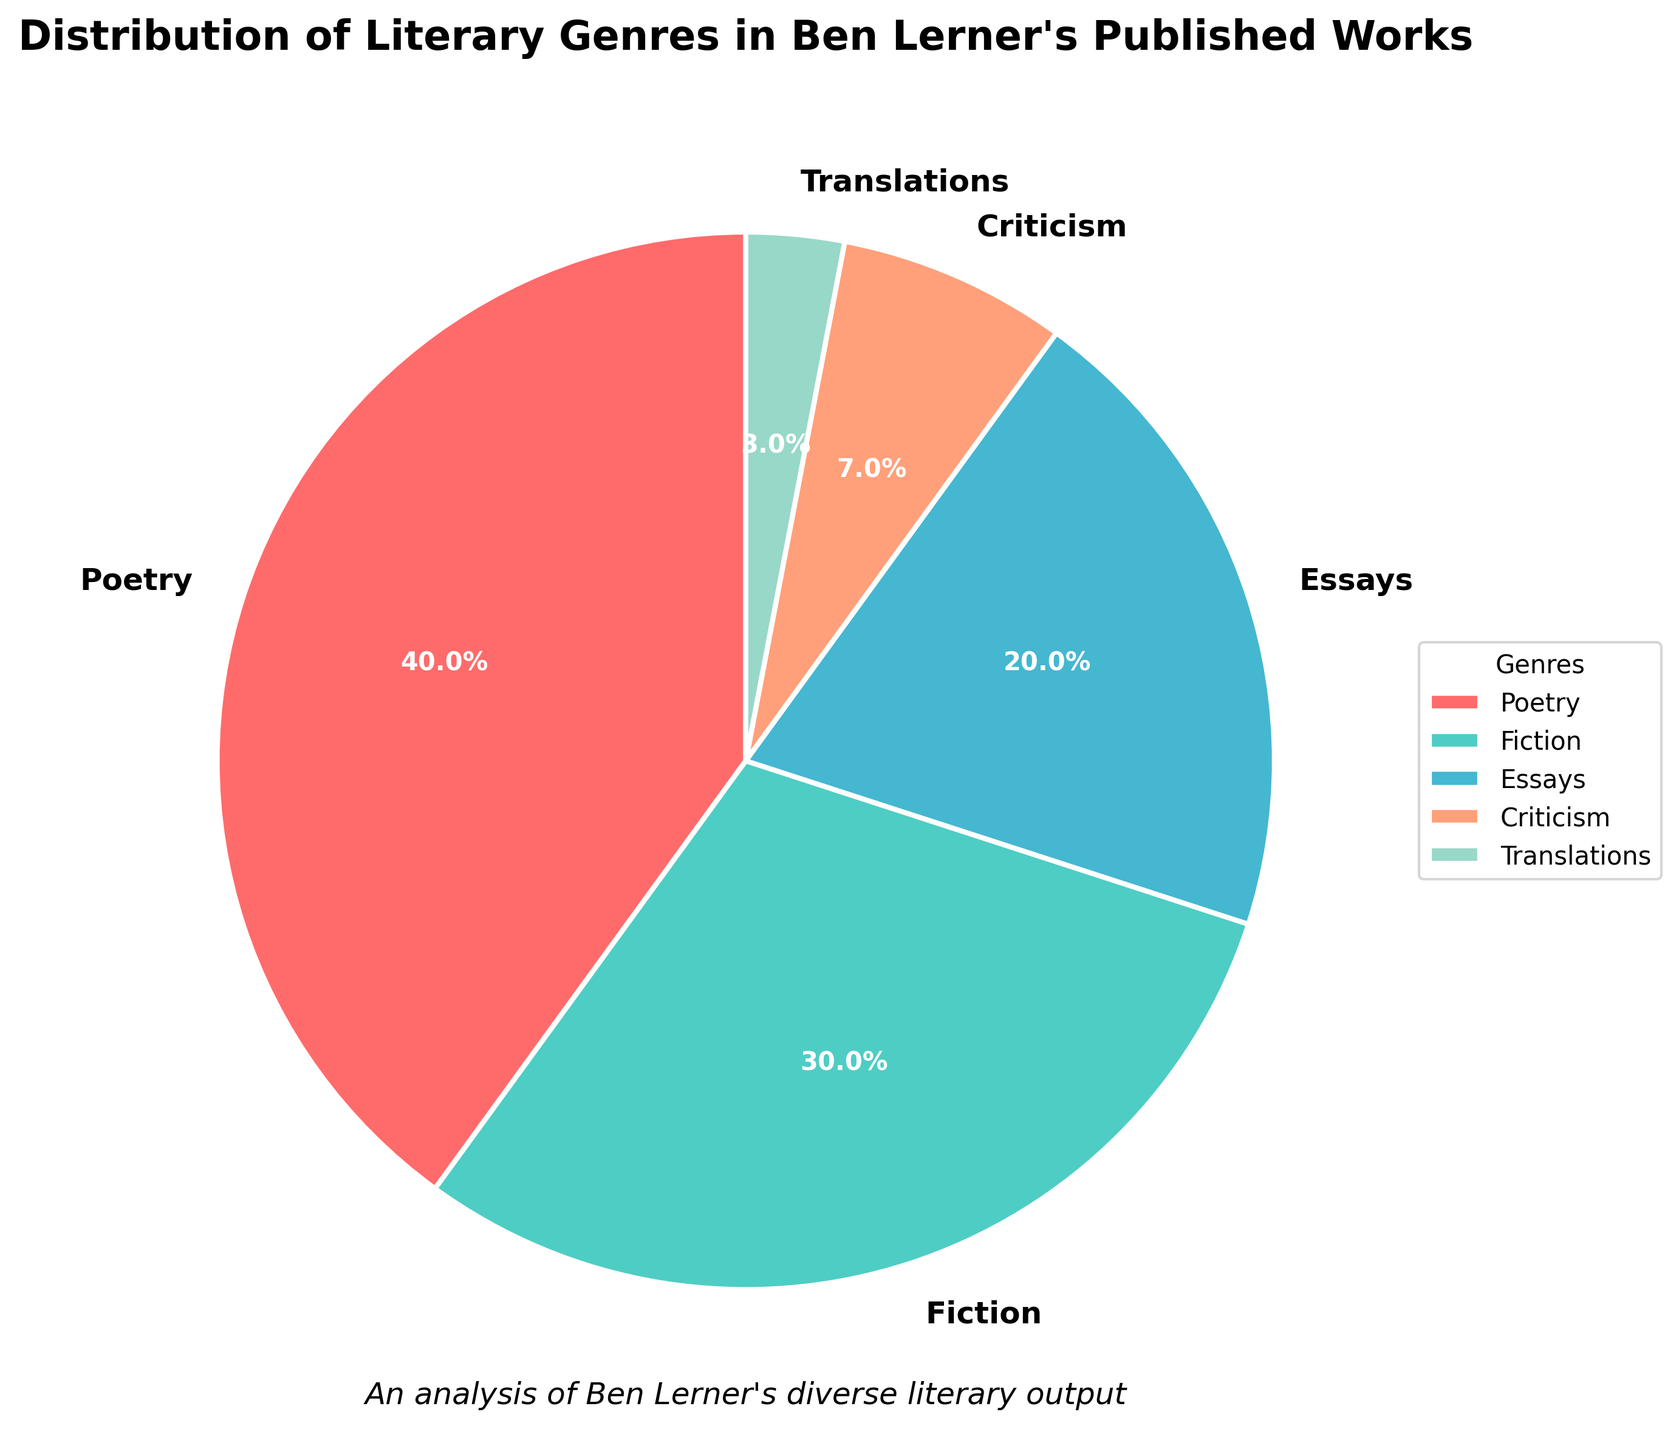What percentage of Ben Lerner's works are poetry? The chart shows that the segment for Poetry occupies 40% of the pie chart.
Answer: 40% Which genre has the smallest share in Ben Lerner's published works? Each segment is labeled with its percentage, and Translations has the smallest slice at 3%.
Answer: Translations How much larger is the Poetry segment compared to the Essays segment? According to the figures, Poetry has 40% and Essays has 20%. The difference is 40% - 20% = 20%.
Answer: 20% Are there more works in Fiction or Criticism? Fiction occupies 30% of the chart, while Criticism occupies 7%, so Fiction has a larger proportion.
Answer: Fiction What is the total percentage of Fiction and Criticism combined? Adding the percentages for Fiction (30%) and Criticism (7%) gives 30% + 7% = 37%.
Answer: 37% Which genre is represented by the segment in green? The legend indicates that the green segment corresponds to Fiction, which is color-coded in the pie chart.
Answer: Fiction What proportion of Ben Lerner's works are non-Fiction genres? Summing up all non-Fiction genres: Poetry (40%), Essays (20%), Criticism (7%), and Translations (3%). The total is 70%.
Answer: 70% Considering Fiction and Translations together, how does their combined percentage compare to Poetry? Fiction is 30% and Translations is 3%, so combined they are 33%. This is 7% less than Poetry which is 40%.
Answer: 7% less Among the genres listed, which two have the closest percentage share of Ben Lerner's published works? Essays and Criticism have the closest percentages: Essays at 20% and Criticism at 7%, but Criticism and Translations are closer, with a difference of 4%.
Answer: Criticism and Translations What is the difference in percentage between the genre with the largest share and the genre with the second-largest share? The largest share is Poetry at 40%, and the second-largest is Fiction at 30%. The difference is 40% - 30% = 10%.
Answer: 10% 